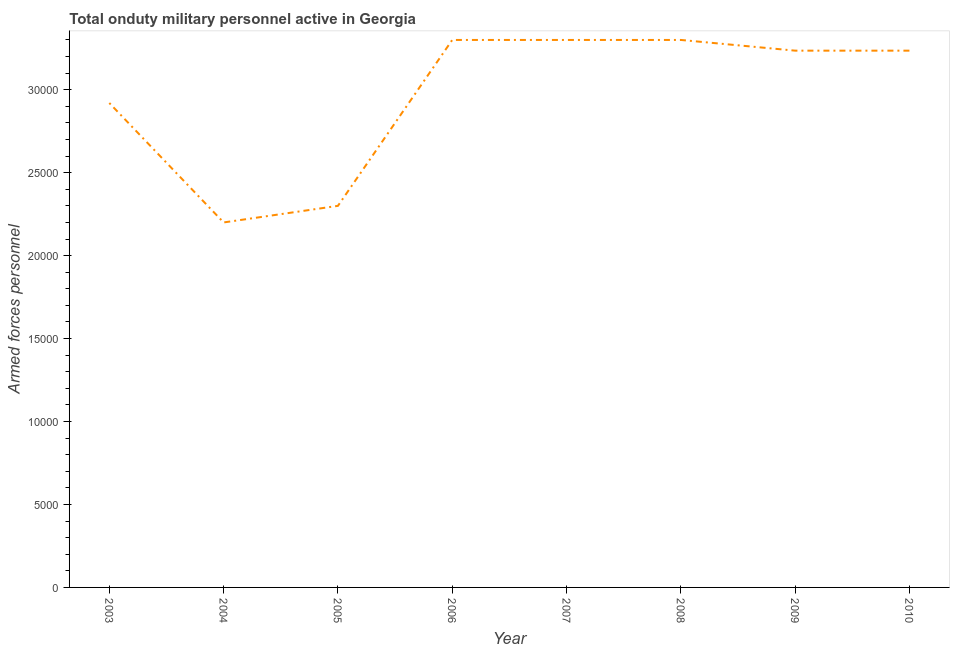What is the number of armed forces personnel in 2003?
Provide a short and direct response. 2.92e+04. Across all years, what is the maximum number of armed forces personnel?
Offer a terse response. 3.30e+04. Across all years, what is the minimum number of armed forces personnel?
Your answer should be compact. 2.20e+04. In which year was the number of armed forces personnel maximum?
Offer a very short reply. 2006. What is the sum of the number of armed forces personnel?
Provide a short and direct response. 2.38e+05. What is the difference between the number of armed forces personnel in 2005 and 2006?
Keep it short and to the point. -10000. What is the average number of armed forces personnel per year?
Your response must be concise. 2.97e+04. What is the median number of armed forces personnel?
Offer a very short reply. 3.24e+04. In how many years, is the number of armed forces personnel greater than 11000 ?
Ensure brevity in your answer.  8. What is the ratio of the number of armed forces personnel in 2006 to that in 2009?
Your response must be concise. 1.02. Is the number of armed forces personnel in 2003 less than that in 2004?
Make the answer very short. No. Is the difference between the number of armed forces personnel in 2006 and 2010 greater than the difference between any two years?
Keep it short and to the point. No. What is the difference between the highest and the second highest number of armed forces personnel?
Ensure brevity in your answer.  0. Is the sum of the number of armed forces personnel in 2003 and 2004 greater than the maximum number of armed forces personnel across all years?
Offer a very short reply. Yes. What is the difference between the highest and the lowest number of armed forces personnel?
Ensure brevity in your answer.  1.10e+04. In how many years, is the number of armed forces personnel greater than the average number of armed forces personnel taken over all years?
Provide a succinct answer. 5. How many lines are there?
Provide a short and direct response. 1. How many years are there in the graph?
Ensure brevity in your answer.  8. What is the difference between two consecutive major ticks on the Y-axis?
Your answer should be compact. 5000. Does the graph contain grids?
Give a very brief answer. No. What is the title of the graph?
Give a very brief answer. Total onduty military personnel active in Georgia. What is the label or title of the Y-axis?
Your answer should be very brief. Armed forces personnel. What is the Armed forces personnel in 2003?
Provide a short and direct response. 2.92e+04. What is the Armed forces personnel of 2004?
Make the answer very short. 2.20e+04. What is the Armed forces personnel in 2005?
Offer a very short reply. 2.30e+04. What is the Armed forces personnel of 2006?
Your response must be concise. 3.30e+04. What is the Armed forces personnel in 2007?
Your answer should be compact. 3.30e+04. What is the Armed forces personnel of 2008?
Keep it short and to the point. 3.30e+04. What is the Armed forces personnel of 2009?
Provide a short and direct response. 3.24e+04. What is the Armed forces personnel in 2010?
Ensure brevity in your answer.  3.24e+04. What is the difference between the Armed forces personnel in 2003 and 2004?
Offer a very short reply. 7200. What is the difference between the Armed forces personnel in 2003 and 2005?
Offer a very short reply. 6200. What is the difference between the Armed forces personnel in 2003 and 2006?
Your answer should be very brief. -3800. What is the difference between the Armed forces personnel in 2003 and 2007?
Make the answer very short. -3800. What is the difference between the Armed forces personnel in 2003 and 2008?
Provide a succinct answer. -3800. What is the difference between the Armed forces personnel in 2003 and 2009?
Give a very brief answer. -3155. What is the difference between the Armed forces personnel in 2003 and 2010?
Give a very brief answer. -3155. What is the difference between the Armed forces personnel in 2004 and 2005?
Keep it short and to the point. -1000. What is the difference between the Armed forces personnel in 2004 and 2006?
Make the answer very short. -1.10e+04. What is the difference between the Armed forces personnel in 2004 and 2007?
Provide a succinct answer. -1.10e+04. What is the difference between the Armed forces personnel in 2004 and 2008?
Offer a terse response. -1.10e+04. What is the difference between the Armed forces personnel in 2004 and 2009?
Your answer should be very brief. -1.04e+04. What is the difference between the Armed forces personnel in 2004 and 2010?
Make the answer very short. -1.04e+04. What is the difference between the Armed forces personnel in 2005 and 2006?
Provide a succinct answer. -10000. What is the difference between the Armed forces personnel in 2005 and 2007?
Give a very brief answer. -10000. What is the difference between the Armed forces personnel in 2005 and 2008?
Give a very brief answer. -10000. What is the difference between the Armed forces personnel in 2005 and 2009?
Your response must be concise. -9355. What is the difference between the Armed forces personnel in 2005 and 2010?
Your response must be concise. -9355. What is the difference between the Armed forces personnel in 2006 and 2007?
Provide a succinct answer. 0. What is the difference between the Armed forces personnel in 2006 and 2009?
Offer a very short reply. 645. What is the difference between the Armed forces personnel in 2006 and 2010?
Ensure brevity in your answer.  645. What is the difference between the Armed forces personnel in 2007 and 2009?
Keep it short and to the point. 645. What is the difference between the Armed forces personnel in 2007 and 2010?
Offer a very short reply. 645. What is the difference between the Armed forces personnel in 2008 and 2009?
Give a very brief answer. 645. What is the difference between the Armed forces personnel in 2008 and 2010?
Offer a terse response. 645. What is the difference between the Armed forces personnel in 2009 and 2010?
Your answer should be compact. 0. What is the ratio of the Armed forces personnel in 2003 to that in 2004?
Offer a very short reply. 1.33. What is the ratio of the Armed forces personnel in 2003 to that in 2005?
Offer a very short reply. 1.27. What is the ratio of the Armed forces personnel in 2003 to that in 2006?
Offer a terse response. 0.89. What is the ratio of the Armed forces personnel in 2003 to that in 2007?
Your response must be concise. 0.89. What is the ratio of the Armed forces personnel in 2003 to that in 2008?
Offer a terse response. 0.89. What is the ratio of the Armed forces personnel in 2003 to that in 2009?
Your answer should be compact. 0.9. What is the ratio of the Armed forces personnel in 2003 to that in 2010?
Keep it short and to the point. 0.9. What is the ratio of the Armed forces personnel in 2004 to that in 2006?
Provide a short and direct response. 0.67. What is the ratio of the Armed forces personnel in 2004 to that in 2007?
Offer a very short reply. 0.67. What is the ratio of the Armed forces personnel in 2004 to that in 2008?
Keep it short and to the point. 0.67. What is the ratio of the Armed forces personnel in 2004 to that in 2009?
Your answer should be very brief. 0.68. What is the ratio of the Armed forces personnel in 2004 to that in 2010?
Ensure brevity in your answer.  0.68. What is the ratio of the Armed forces personnel in 2005 to that in 2006?
Keep it short and to the point. 0.7. What is the ratio of the Armed forces personnel in 2005 to that in 2007?
Provide a succinct answer. 0.7. What is the ratio of the Armed forces personnel in 2005 to that in 2008?
Keep it short and to the point. 0.7. What is the ratio of the Armed forces personnel in 2005 to that in 2009?
Provide a succinct answer. 0.71. What is the ratio of the Armed forces personnel in 2005 to that in 2010?
Keep it short and to the point. 0.71. What is the ratio of the Armed forces personnel in 2006 to that in 2007?
Offer a very short reply. 1. What is the ratio of the Armed forces personnel in 2006 to that in 2010?
Keep it short and to the point. 1.02. What is the ratio of the Armed forces personnel in 2007 to that in 2008?
Offer a very short reply. 1. What is the ratio of the Armed forces personnel in 2007 to that in 2009?
Provide a short and direct response. 1.02. What is the ratio of the Armed forces personnel in 2007 to that in 2010?
Keep it short and to the point. 1.02. What is the ratio of the Armed forces personnel in 2008 to that in 2010?
Keep it short and to the point. 1.02. 